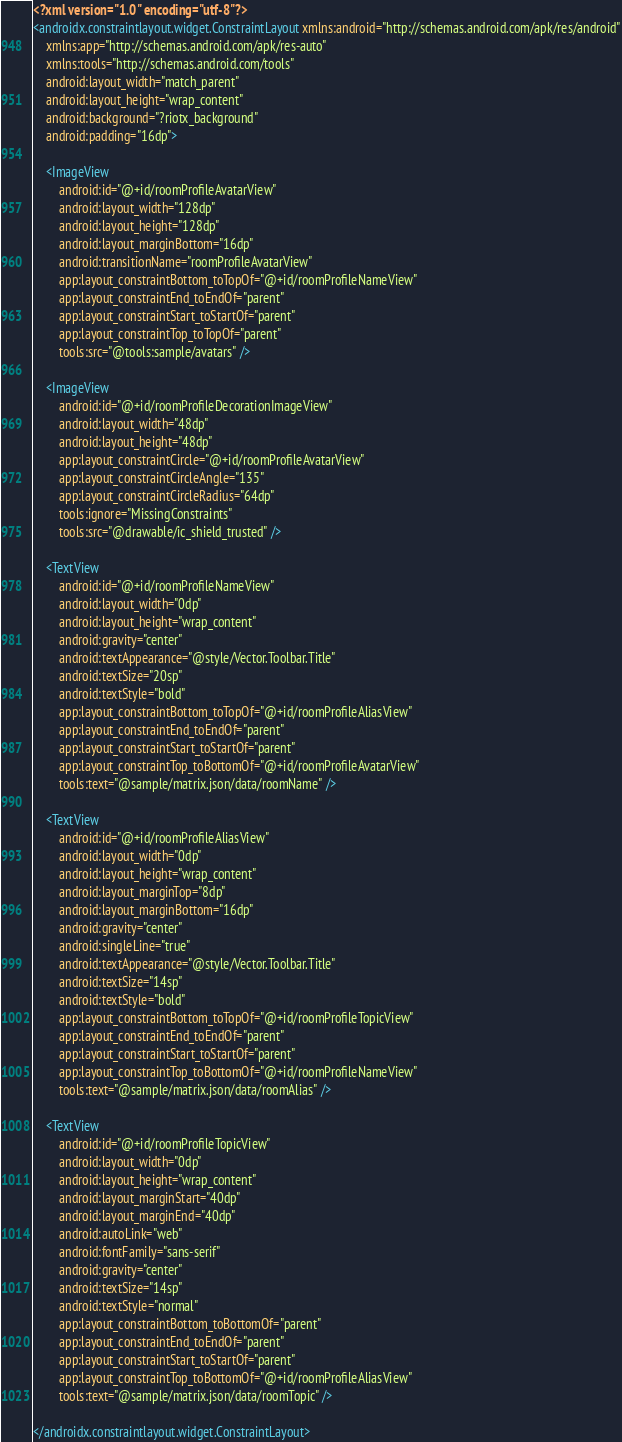Convert code to text. <code><loc_0><loc_0><loc_500><loc_500><_XML_><?xml version="1.0" encoding="utf-8"?>
<androidx.constraintlayout.widget.ConstraintLayout xmlns:android="http://schemas.android.com/apk/res/android"
    xmlns:app="http://schemas.android.com/apk/res-auto"
    xmlns:tools="http://schemas.android.com/tools"
    android:layout_width="match_parent"
    android:layout_height="wrap_content"
    android:background="?riotx_background"
    android:padding="16dp">

    <ImageView
        android:id="@+id/roomProfileAvatarView"
        android:layout_width="128dp"
        android:layout_height="128dp"
        android:layout_marginBottom="16dp"
        android:transitionName="roomProfileAvatarView"
        app:layout_constraintBottom_toTopOf="@+id/roomProfileNameView"
        app:layout_constraintEnd_toEndOf="parent"
        app:layout_constraintStart_toStartOf="parent"
        app:layout_constraintTop_toTopOf="parent"
        tools:src="@tools:sample/avatars" />

    <ImageView
        android:id="@+id/roomProfileDecorationImageView"
        android:layout_width="48dp"
        android:layout_height="48dp"
        app:layout_constraintCircle="@+id/roomProfileAvatarView"
        app:layout_constraintCircleAngle="135"
        app:layout_constraintCircleRadius="64dp"
        tools:ignore="MissingConstraints"
        tools:src="@drawable/ic_shield_trusted" />

    <TextView
        android:id="@+id/roomProfileNameView"
        android:layout_width="0dp"
        android:layout_height="wrap_content"
        android:gravity="center"
        android:textAppearance="@style/Vector.Toolbar.Title"
        android:textSize="20sp"
        android:textStyle="bold"
        app:layout_constraintBottom_toTopOf="@+id/roomProfileAliasView"
        app:layout_constraintEnd_toEndOf="parent"
        app:layout_constraintStart_toStartOf="parent"
        app:layout_constraintTop_toBottomOf="@+id/roomProfileAvatarView"
        tools:text="@sample/matrix.json/data/roomName" />

    <TextView
        android:id="@+id/roomProfileAliasView"
        android:layout_width="0dp"
        android:layout_height="wrap_content"
        android:layout_marginTop="8dp"
        android:layout_marginBottom="16dp"
        android:gravity="center"
        android:singleLine="true"
        android:textAppearance="@style/Vector.Toolbar.Title"
        android:textSize="14sp"
        android:textStyle="bold"
        app:layout_constraintBottom_toTopOf="@+id/roomProfileTopicView"
        app:layout_constraintEnd_toEndOf="parent"
        app:layout_constraintStart_toStartOf="parent"
        app:layout_constraintTop_toBottomOf="@+id/roomProfileNameView"
        tools:text="@sample/matrix.json/data/roomAlias" />

    <TextView
        android:id="@+id/roomProfileTopicView"
        android:layout_width="0dp"
        android:layout_height="wrap_content"
        android:layout_marginStart="40dp"
        android:layout_marginEnd="40dp"
        android:autoLink="web"
        android:fontFamily="sans-serif"
        android:gravity="center"
        android:textSize="14sp"
        android:textStyle="normal"
        app:layout_constraintBottom_toBottomOf="parent"
        app:layout_constraintEnd_toEndOf="parent"
        app:layout_constraintStart_toStartOf="parent"
        app:layout_constraintTop_toBottomOf="@+id/roomProfileAliasView"
        tools:text="@sample/matrix.json/data/roomTopic" />

</androidx.constraintlayout.widget.ConstraintLayout>
</code> 